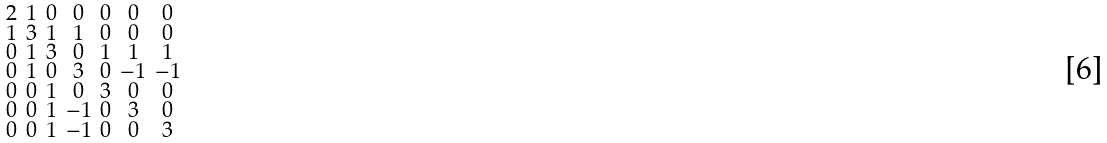<formula> <loc_0><loc_0><loc_500><loc_500>\begin{smallmatrix} 2 & 1 & 0 & 0 & 0 & 0 & 0 \\ 1 & 3 & 1 & 1 & 0 & 0 & 0 \\ 0 & 1 & 3 & 0 & 1 & 1 & 1 \\ 0 & 1 & 0 & 3 & 0 & - 1 & - 1 \\ 0 & 0 & 1 & 0 & 3 & 0 & 0 \\ 0 & 0 & 1 & - 1 & 0 & 3 & 0 \\ 0 & 0 & 1 & - 1 & 0 & 0 & 3 \end{smallmatrix}</formula> 